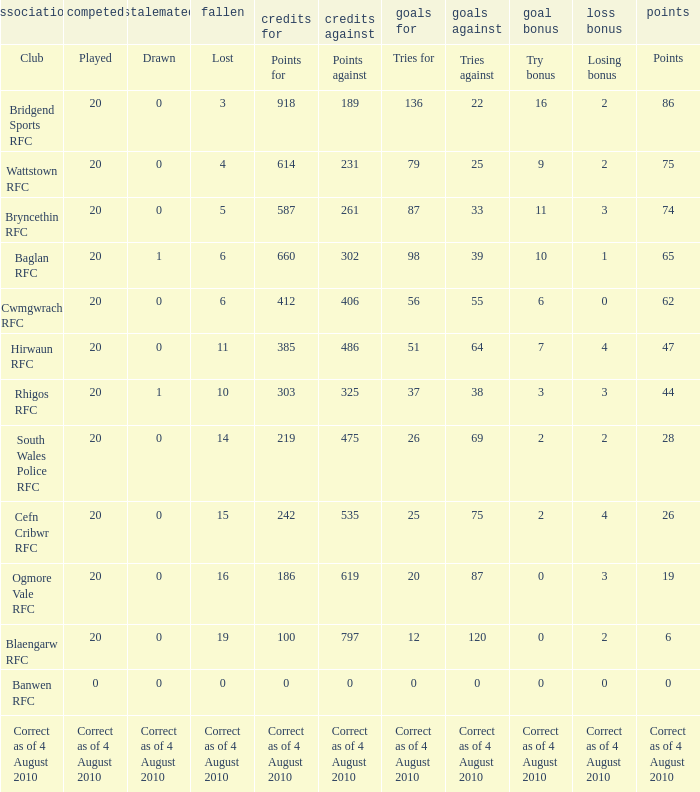What is lost when the points against is 231? 4.0. 